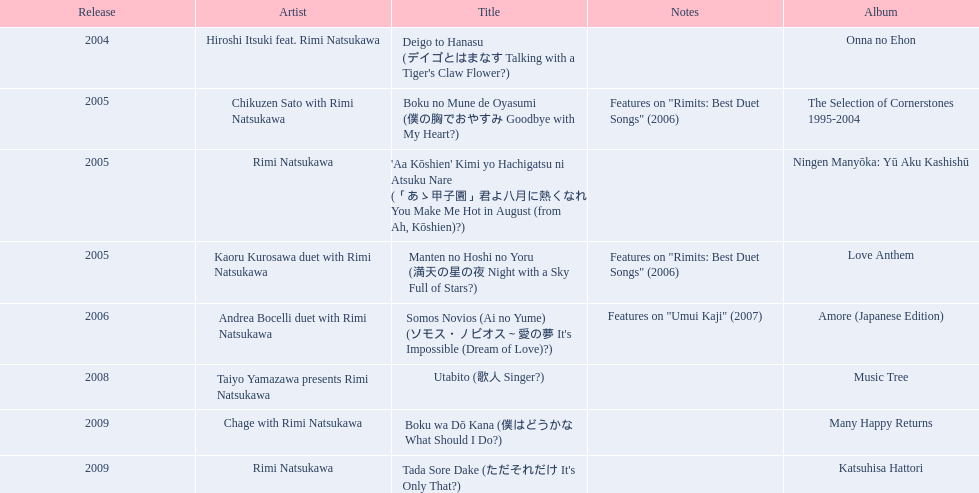What are the pitches for a sky full of stars? Features on "Rimits: Best Duet Songs" (2006). What other melody includes these same pitches? Boku no Mune de Oyasumi (僕の胸でおやすみ Goodbye with My Heart?). 